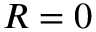Convert formula to latex. <formula><loc_0><loc_0><loc_500><loc_500>R = 0</formula> 